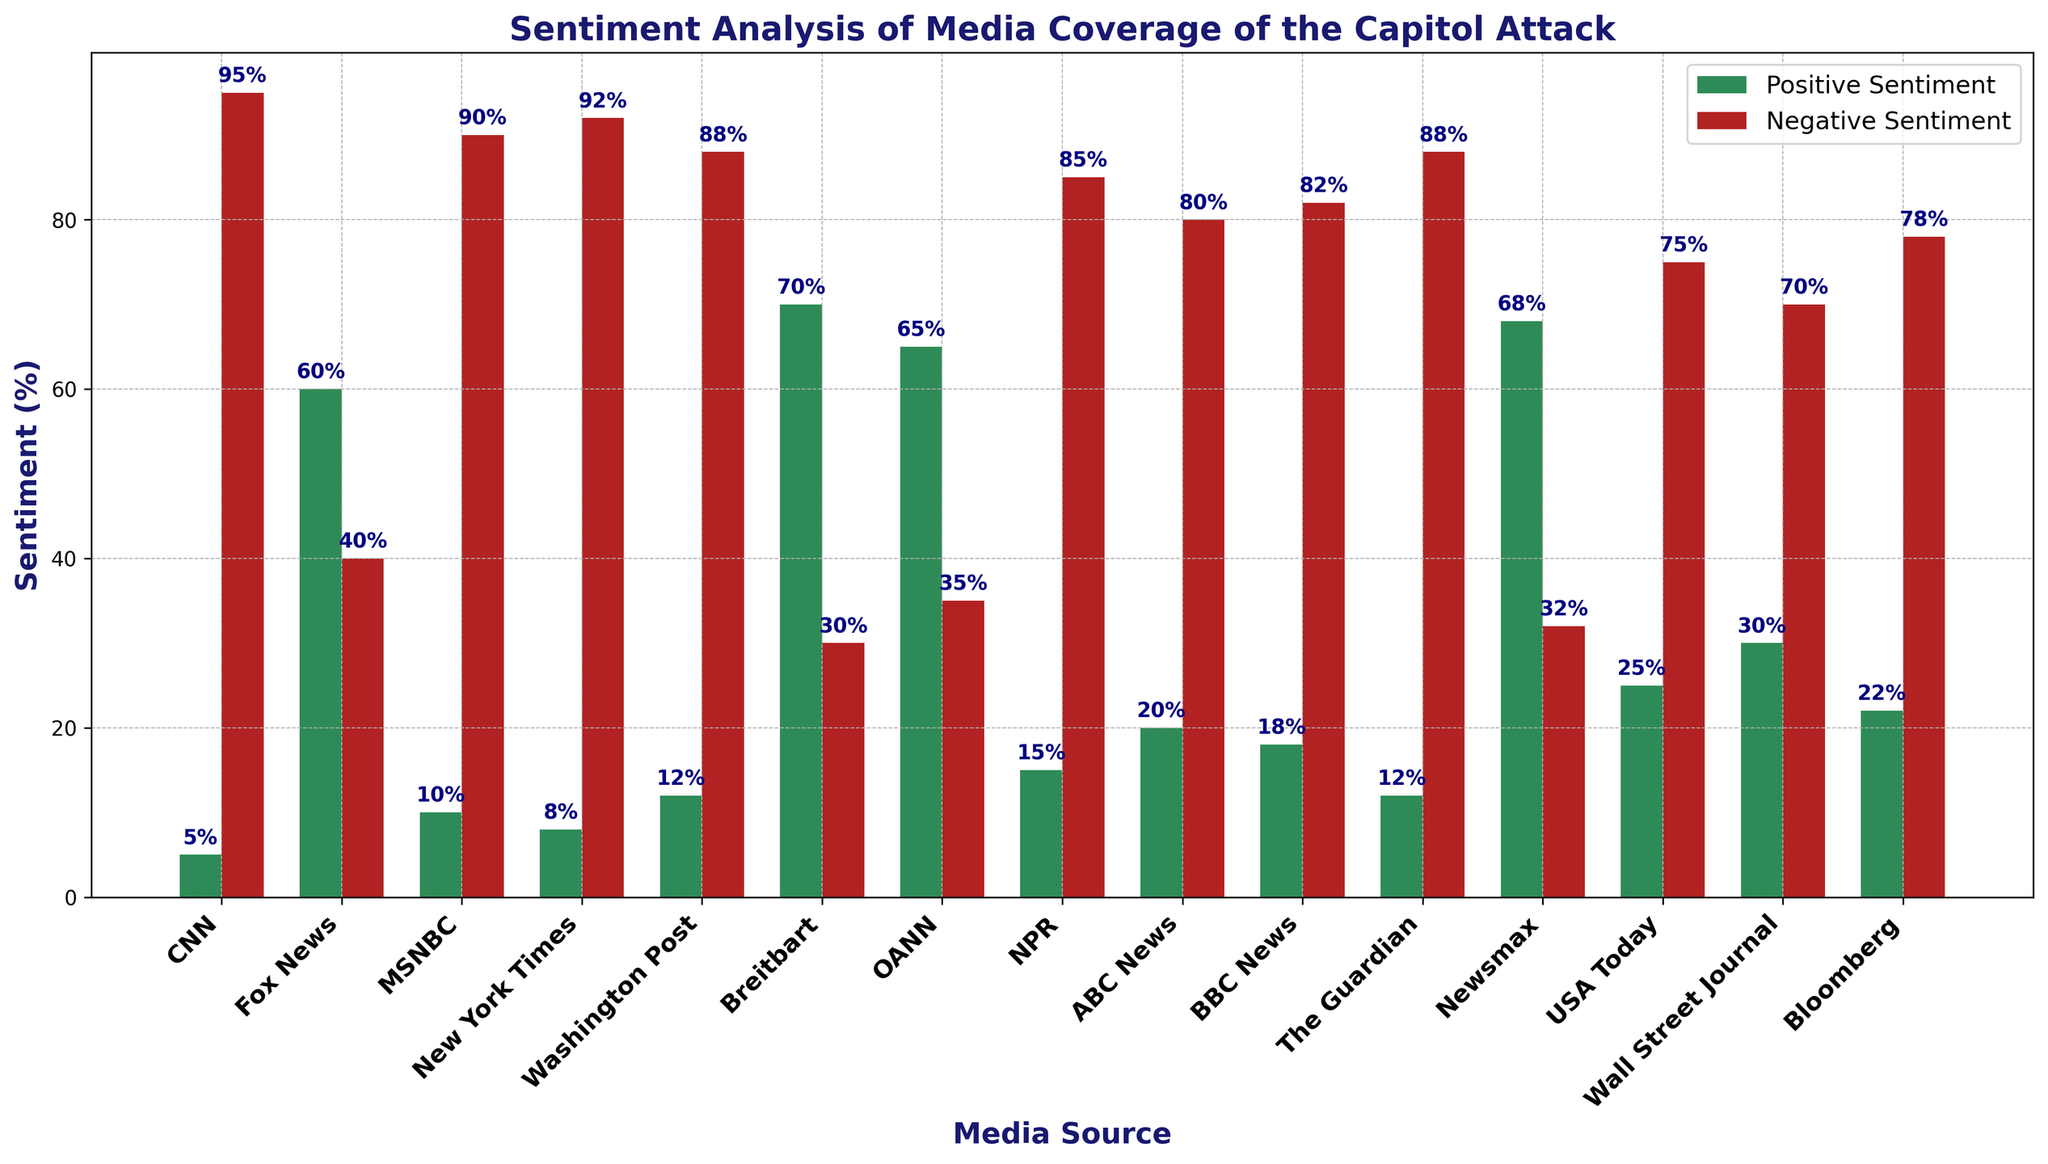Which media source has the highest positive sentiment? By observing which bar in the positive sentiment category is the tallest, we can determine that Breitbart has the highest positive sentiment.
Answer: Breitbart Which media source has the lowest negative sentiment? By observing which bar in the negative sentiment category is the shortest, we can determine that Breitbart has the lowest negative sentiment.
Answer: Breitbart Which two media sources have the most similar sentiment distribution (positive and negative combined)? By comparing the lengths of the bars for each media source in both positive and negative sentiment, it seems like OANN and Newsmax have the closest distribution.
Answer: OANN and Newsmax What is the difference in positive sentiment between Fox News and CNN? Fox News has a positive sentiment of 60% and CNN has 5%, so the difference is 60 - 5 = 55%.
Answer: 55% Which media source shows the largest disparity between positive and negative sentiment? By looking for the largest difference between the positive and negative sentiment bars, CNN has 5% positive and 95% negative, a disparity of 90%.
Answer: CNN What is the average positive sentiment percentage across all media sources? (5 + 60 + 10 + 8 + 12 + 70 + 65 + 15 + 20 + 18 + 12 + 68 + 25 + 30 + 22) / 15 = 28.67%.
Answer: 28.67% Is there any media source with positive sentiment greater than its negative sentiment? By comparing the heights of the positive and negative sentiment bars for each media source, we find that only Breitbart and OANN have positive sentiment greater than its negative sentiment.
Answer: Breitbart and OANN Which media sources have negative sentiment percentages exceeding 75%? By checking which bars in the negative sentiment category are taller than 75%, we identify: CNN, MSNBC, New York Times, Washington Post, NPR, ABC News, BBC News, The Guardian, USA Today, and Bloomberg.
Answer: CNN, MSNBC, New York Times, Washington Post, NPR, ABC News, BBC News, The Guardian, USA Today, Bloomberg What's the combined positive sentiment percentage for Fox News, Breitbart, and OANN? Fox News has 60%, Breitbart has 70%, and OANN has 65%. Summing these up: 60 + 70 + 65 = 195%.
Answer: 195% Which media source has closest to twice the positive sentiment percentage of ABC News? ABC News has 20% positive sentiment. Twice that is 40%. Wall Street Journal has 30%, which is closest to 40% compared to other sources.
Answer: Wall Street Journal 